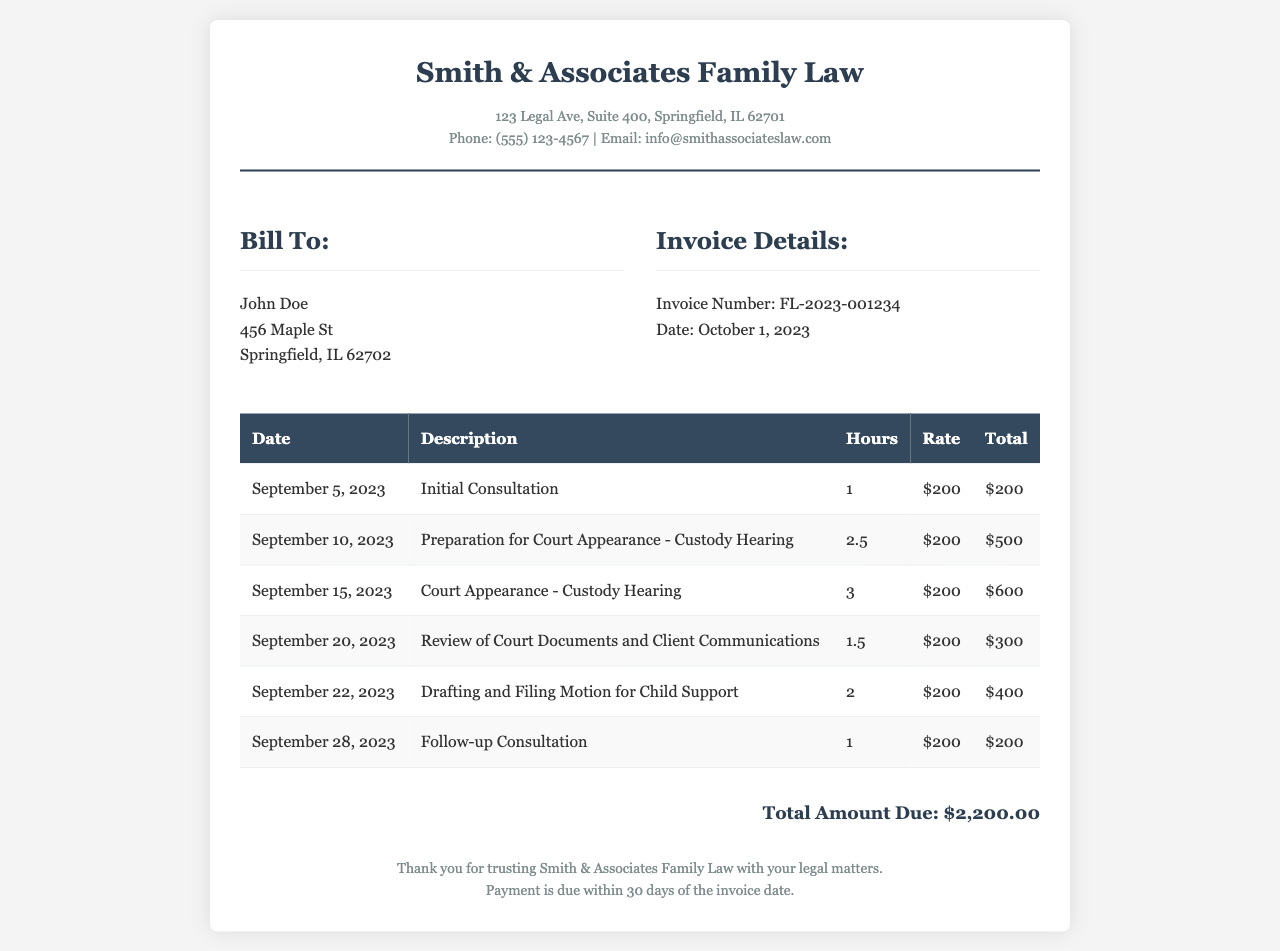What is the invoice number? The invoice number is listed in the invoice details section.
Answer: FL-2023-001234 What is the total amount due? The total amount due is found at the bottom of the invoice.
Answer: $2,200.00 Who is the client? The client's name is provided in the billing section.
Answer: John Doe When was the initial consultation? The date of the initial consultation is listed in the itemized services section.
Answer: September 5, 2023 How many hours were spent on the court appearance for the custody hearing? The hours for the court appearance can be found in the details of the court appearance service.
Answer: 3 What service was provided on September 20, 2023? The description of services includes a list by date.
Answer: Review of Court Documents and Client Communications What is the hourly rate charged for the services? The hourly rate is specified in each line item of the invoice.
Answer: $200 What type of law matter is this invoice related to? The type of law matter is indicated in the firm name and invoice title.
Answer: Family Law How many consultations were conducted for this case? The consultations are itemized in the services section.
Answer: 2 